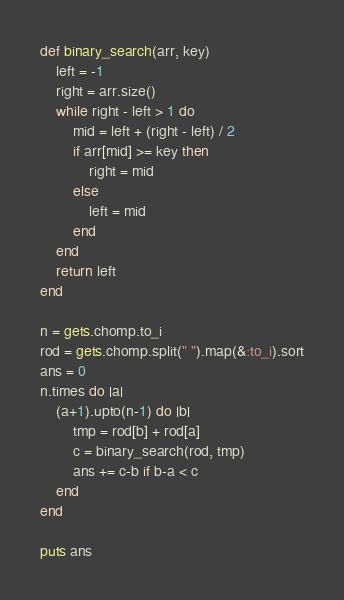Convert code to text. <code><loc_0><loc_0><loc_500><loc_500><_Ruby_>def binary_search(arr, key)
    left = -1
    right = arr.size()
    while right - left > 1 do
        mid = left + (right - left) / 2
        if arr[mid] >= key then
            right = mid
        else
            left = mid
        end
    end
    return left
end

n = gets.chomp.to_i
rod = gets.chomp.split(" ").map(&:to_i).sort
ans = 0
n.times do |a|
    (a+1).upto(n-1) do |b|
        tmp = rod[b] + rod[a]
        c = binary_search(rod, tmp)
        ans += c-b if b-a < c
    end
end

puts ans</code> 